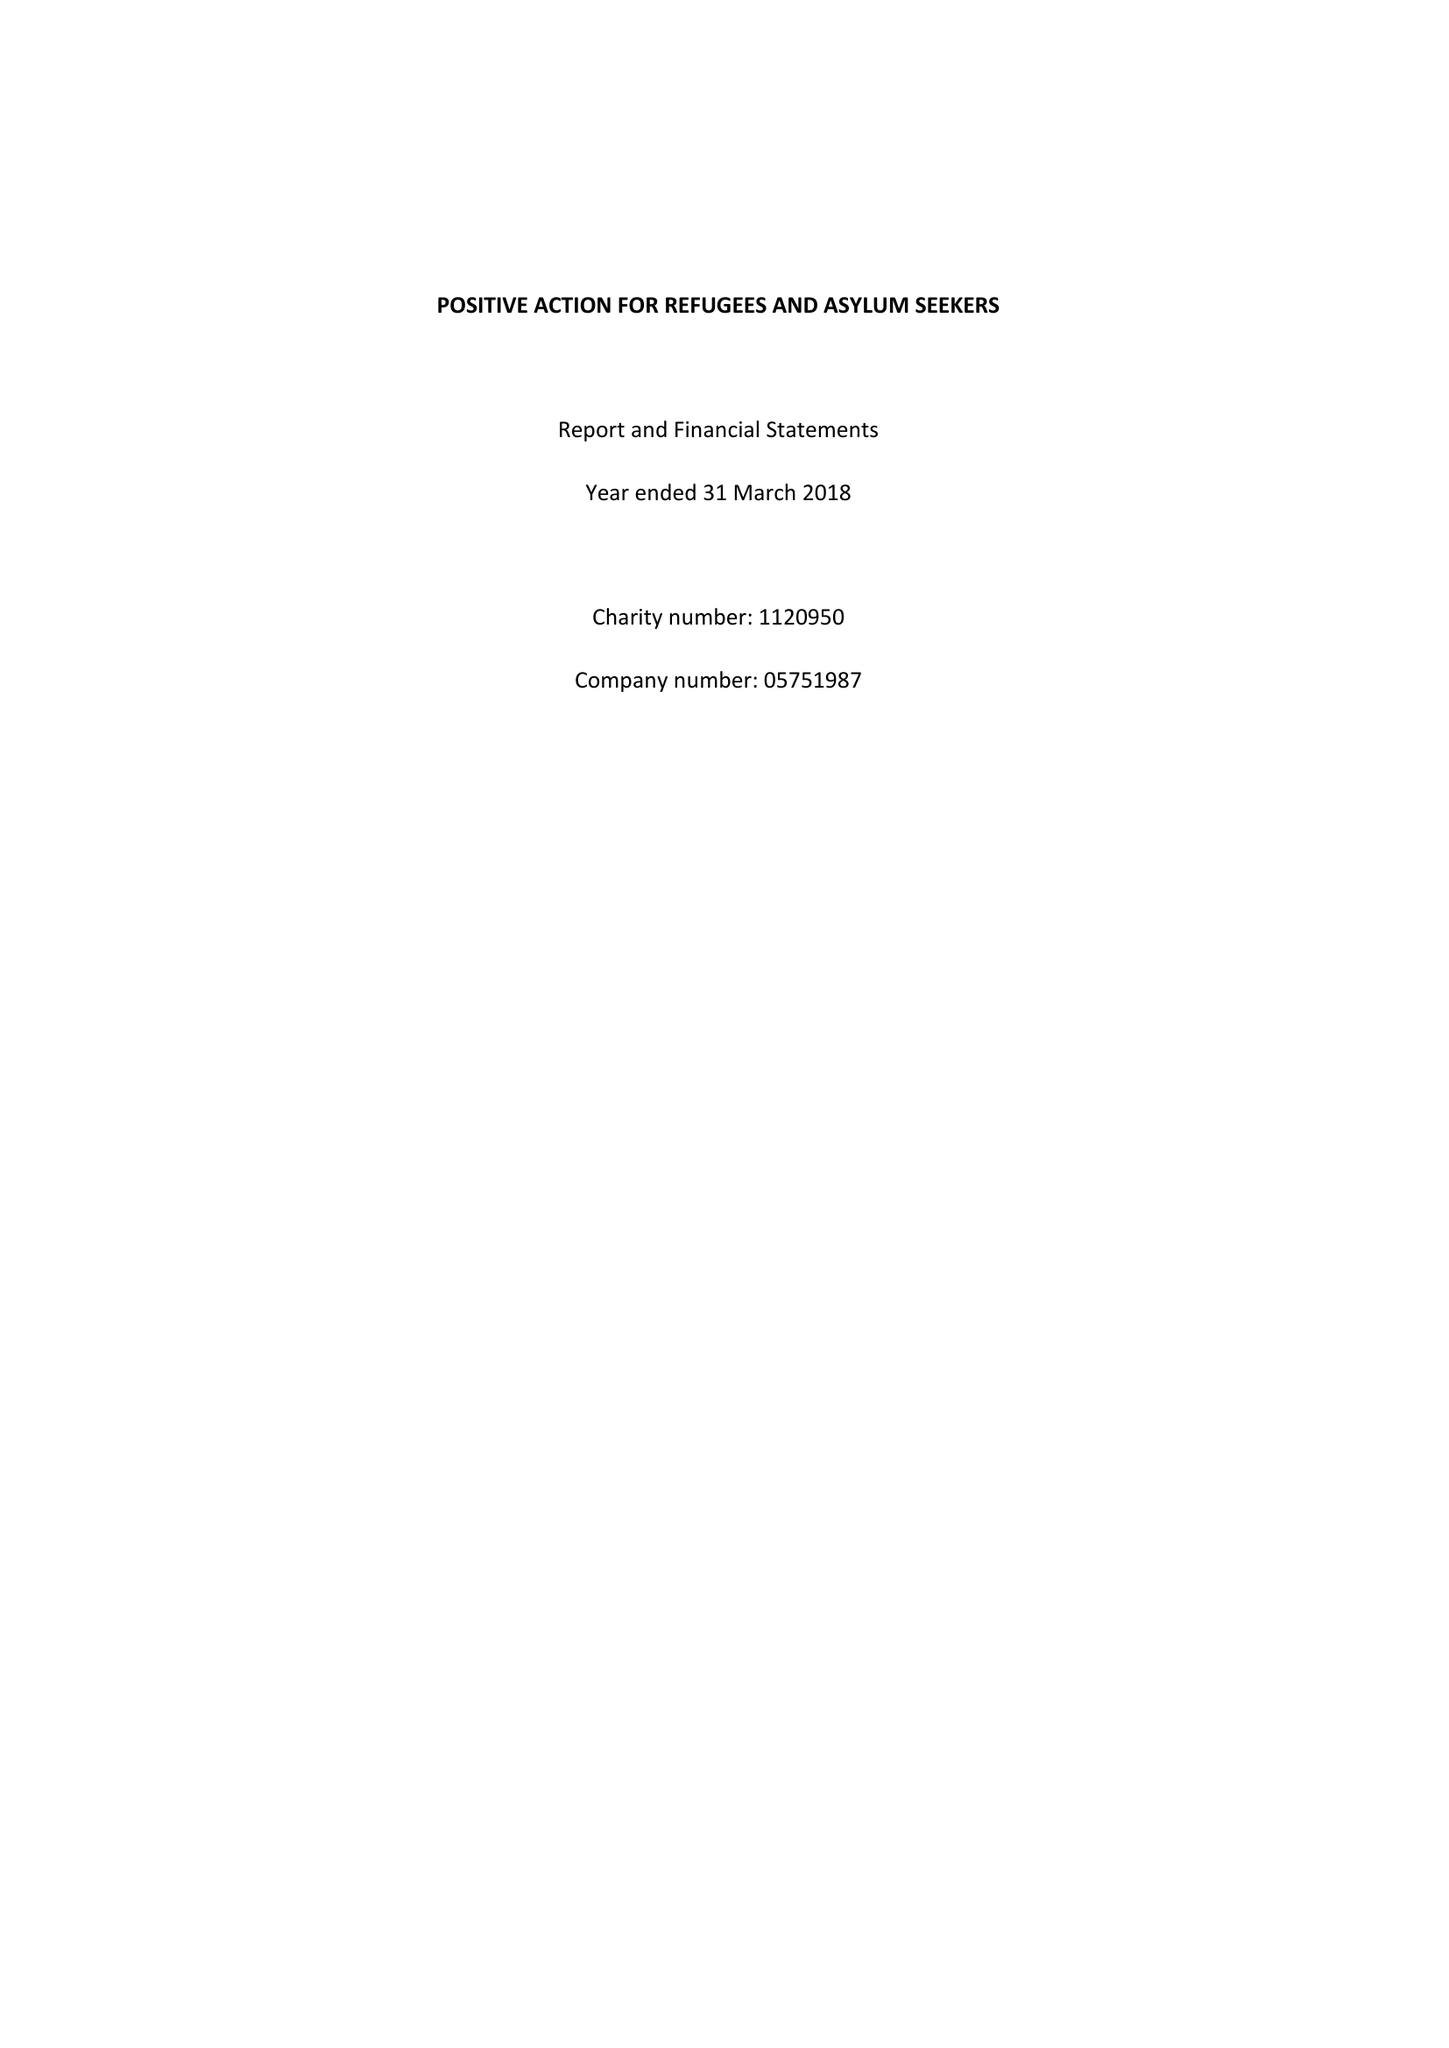What is the value for the address__postcode?
Answer the question using a single word or phrase. LS7 1AB 